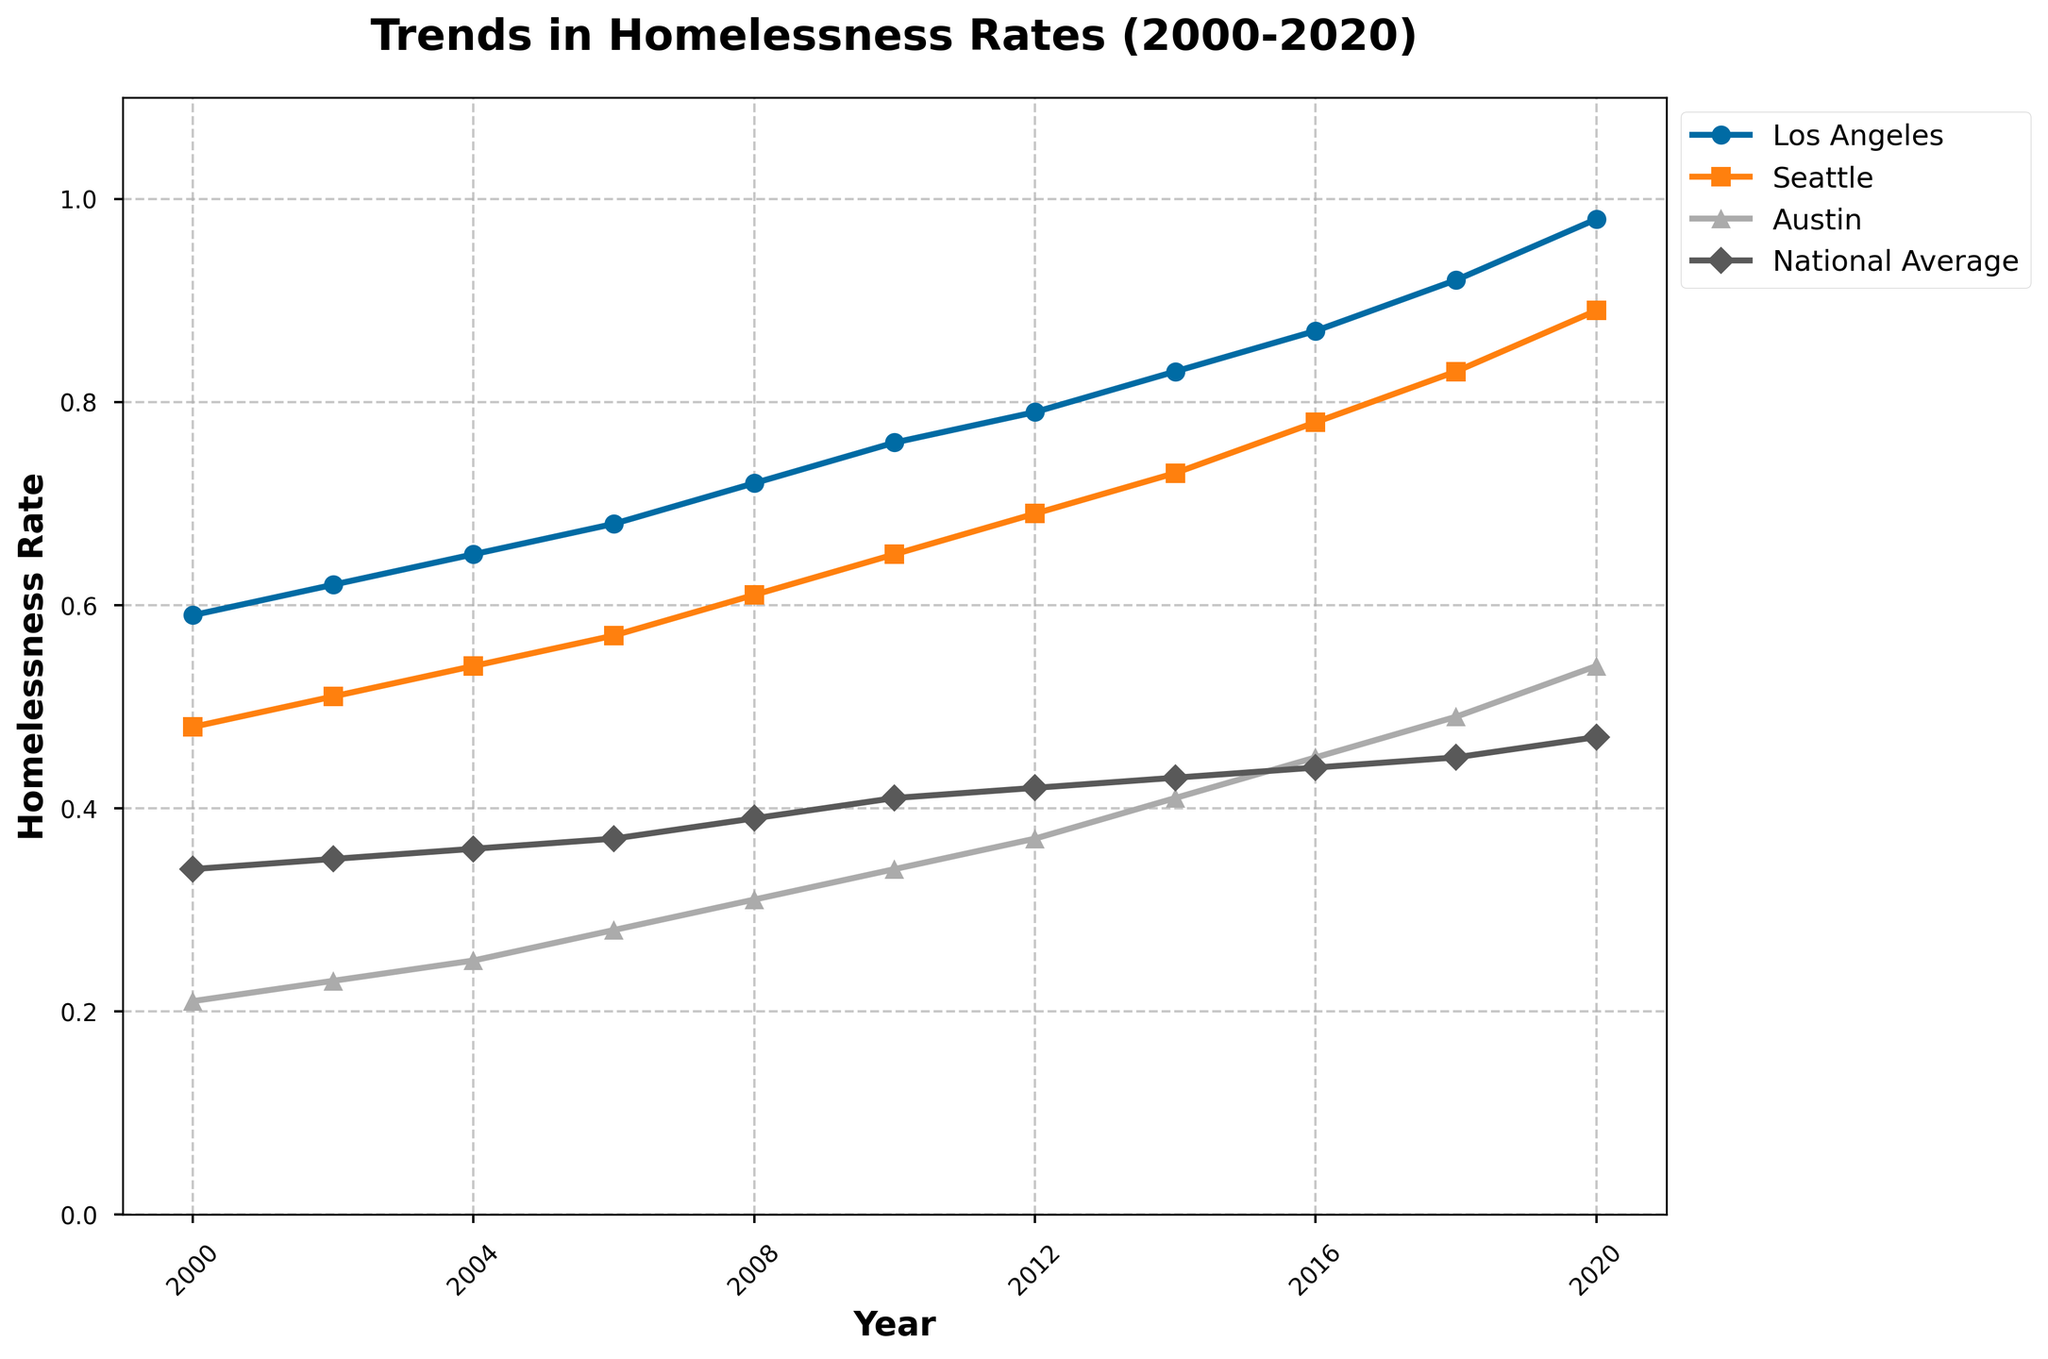What was the homelessness rate in Los Angeles in 2020? Look at the plot for Los Angeles in the year 2020. The rate is marked with a specific shape (circle) and color.
Answer: 0.98 Which city had the lower homelessness rate in 2008, Seattle or Austin? Compare the heights of the lines for Seattle and Austin in the year 2008. Seattle's line is higher, indicating a higher rate. Therefore, Austin had a lower rate.
Answer: Austin By how much did the homelessness rate increase in Seattle from 2000 to 2020? Check the value for Seattle in 2000 (0.48) and in 2020 (0.89). Subtract the 2000 value from the 2020 value: 0.89 - 0.48.
Answer: 0.41 Which city had the highest homelessness rate in 2014? Compare the heights of the lines for all cities in 2014. The line for Los Angeles is the highest.
Answer: Los Angeles How did the homelessness rate in Austin change between 2006 and 2016? Look at the values for Austin in 2006 (0.28) and 2016 (0.45). Subtract the 2006 value from the 2016 value: 0.45 - 0.28.
Answer: Increased by 0.17 What is the trend of the national average homelessness rate from 2000 to 2020? Observe the general direction of the line for the National Average from 2000 to 2020. It shows a gradual increase from 0.34 to 0.47.
Answer: Gradually increasing Compare the homelessness rate trends of Los Angeles and the National Average. Observe both lines from 2000 to 2020. Los Angeles consistently has a higher rate than the National Average and increases more steeply.
Answer: Los Angeles increases more steeply and is consistently higher What is the difference in the homelessness rates between Los Angeles and Seattle in 2016? Find the values for Los Angeles (0.87) and Seattle (0.78) in 2016. Subtract the Seattle value from the Los Angeles value: 0.87 - 0.78.
Answer: 0.09 By what percentage did the homelessness rate in Austin increase from 2000 to 2020? Check the values for Austin in 2000 (0.21) and 2020 (0.54). Subtract 2000 from 2020 and divide by the 2000 value: (0.54 - 0.21) / 0.21 * 100%.
Answer: 157.14% How does the rate of homelessness growth in Seattle compare to Austin between 2000 and 2020? Find values for Seattle in 2000 (0.48) and 2020 (0.89) and Austin in 2000 (0.21) and 2020 (0.54). Calculate the differences: Seattle (0.89 - 0.48 = 0.41), Austin (0.54 - 0.21 = 0.33). Compare the differences.
Answer: Seattle increased by 0.41, Austin by 0.33 